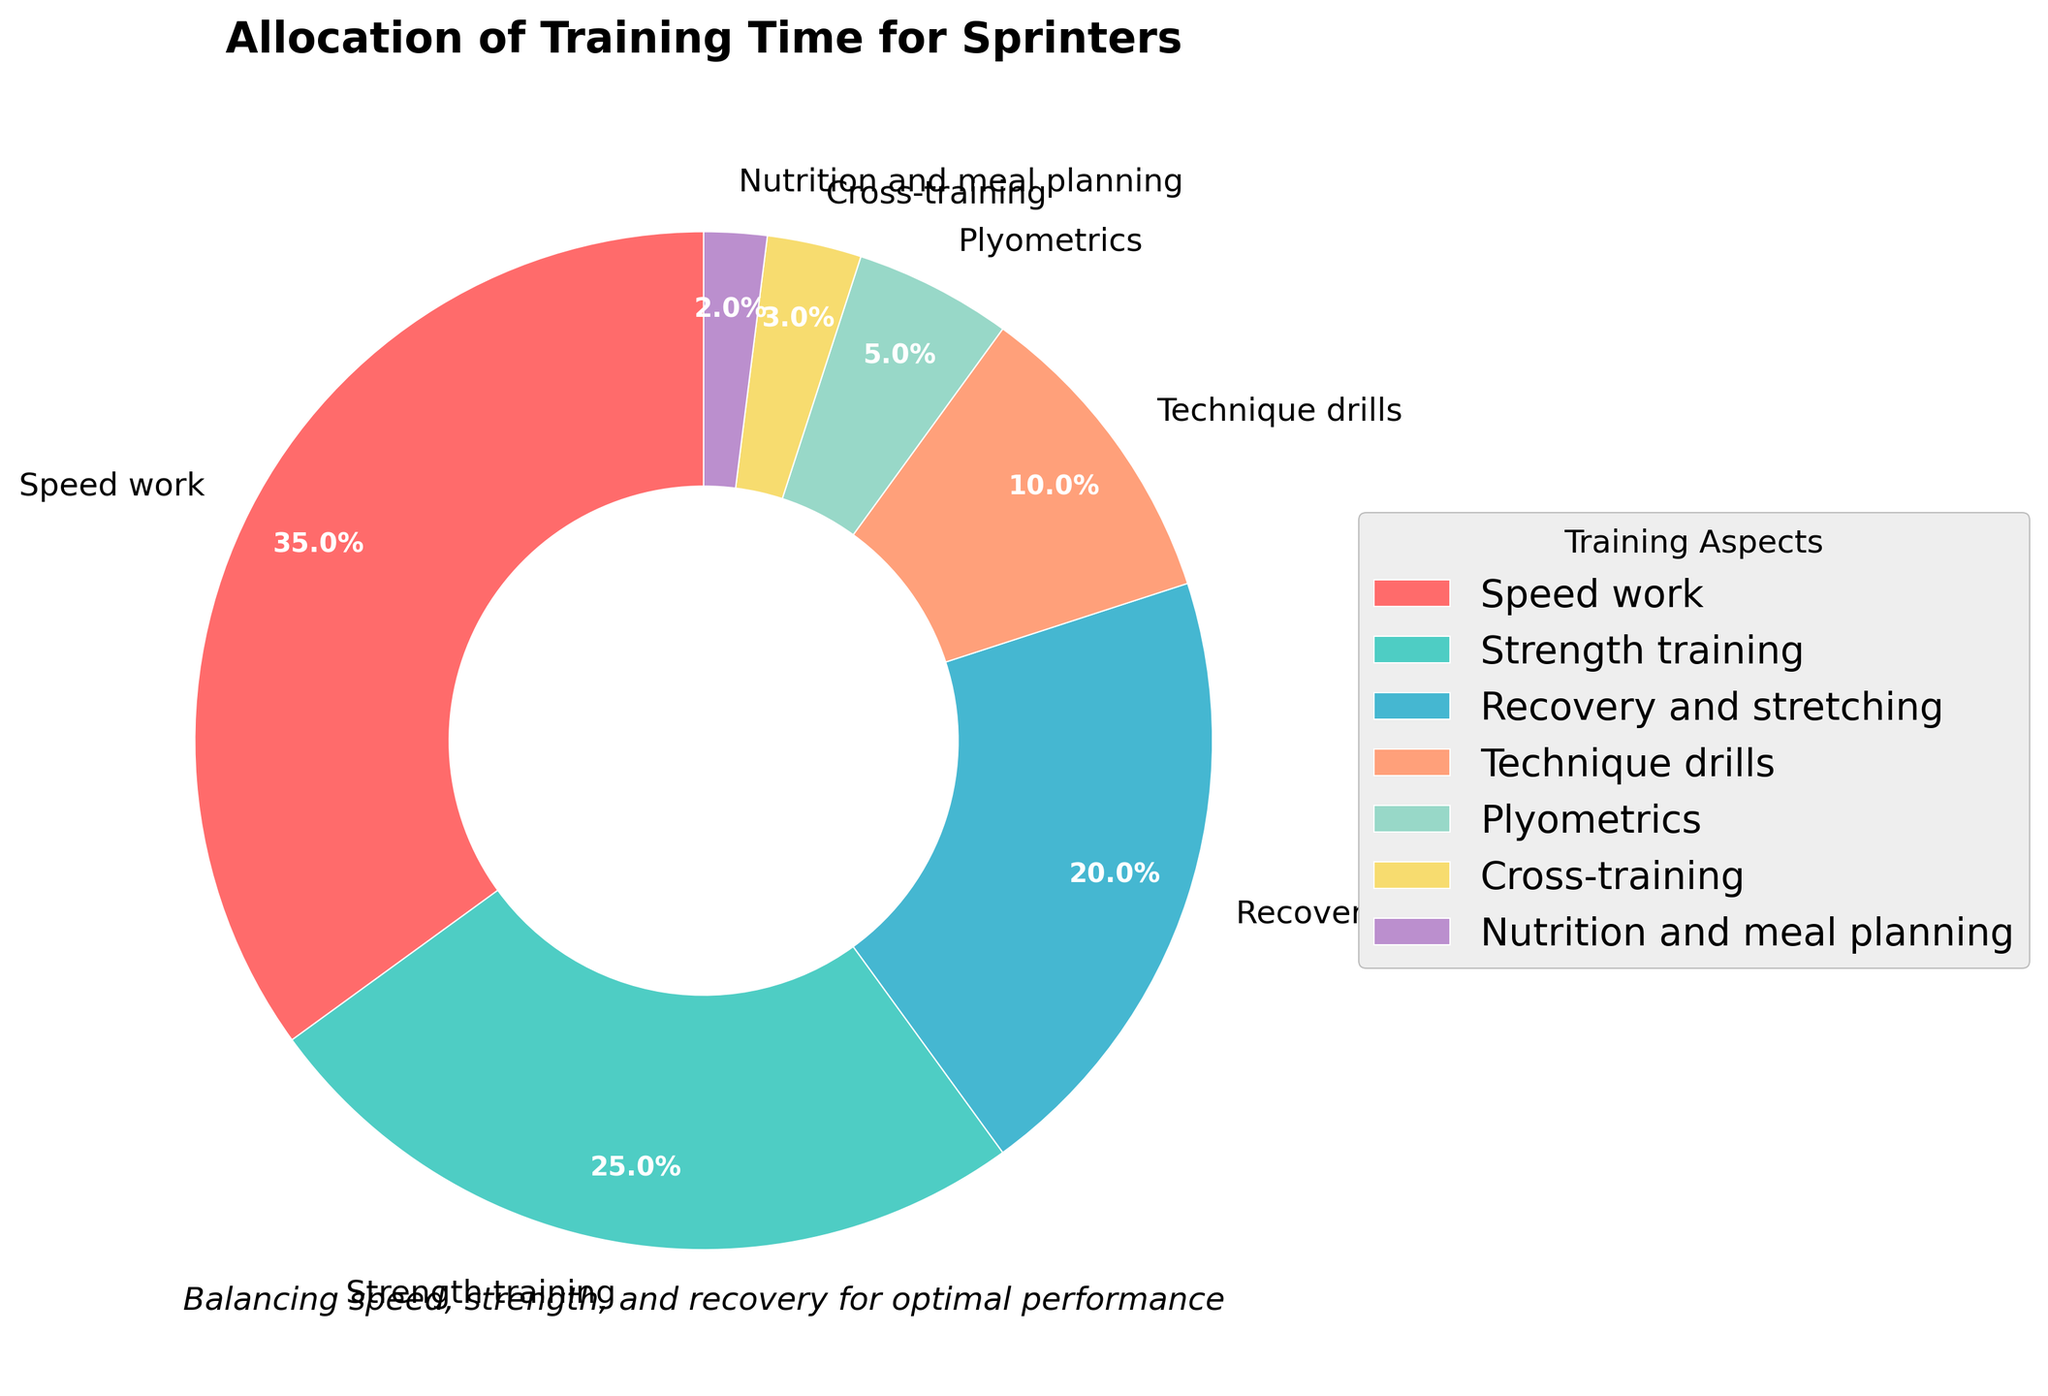What's the largest category by percentage? The slice representing 'Speed work' is visually the largest, and the label shows it covering 35%.
Answer: Speed work What's the combined percentage of 'Technique drills' and 'Plyometrics'? The 'Technique drills' slice is labeled as 10% and the 'Plyometrics' slice as 5%. Adding these two values gives 10% + 5% = 15%.
Answer: 15% How much more percentage is allocated to 'Speed work' compared to 'Nutrition and meal planning'? The 'Speed work' slice is labeled 35%, while 'Nutrition and meal planning' is 2%. Subtracting these values gives 35% - 2% = 33%.
Answer: 33% Are there any categories with equal percentages? By examining the pie chart, we see that all provided percentages are unique: 35%, 25%, 20%, 10%, 5%, 3%, and 2%. Therefore, no categories have equal percentages.
Answer: No What is the difference between the highest and lowest category percentages? The highest percentage is for 'Speed work' at 35%, and the lowest is 'Nutrition and meal planning' at 2%. Subtracting these gives 35% - 2% = 33%.
Answer: 33% Which category has the second highest percentage? After 'Speed work' (35%), the next largest slice is 'Strength training', which is marked as 25%.
Answer: Strength training What percentage is allocated to 'Cross-training'? The pie chart shows a slice for 'Cross-training', which is labeled as 3%.
Answer: 3% What is the total percentage allocated to 'Strength training' and 'Recovery and stretching'? The 'Strength training' slice is 25%, and 'Recovery and stretching' is 20%. Adding these together results in 25% + 20% = 45%.
Answer: 45% Which category occupies a larger share: 'Recovery and stretching' or 'Technique drills'? Visually comparing the slices, 'Recovery and stretching' (20%) is larger than 'Technique drills' (10%).
Answer: Recovery and stretching What color represents 'Speed work'? The slice labeled 'Speed work' is colored in red.
Answer: Red 